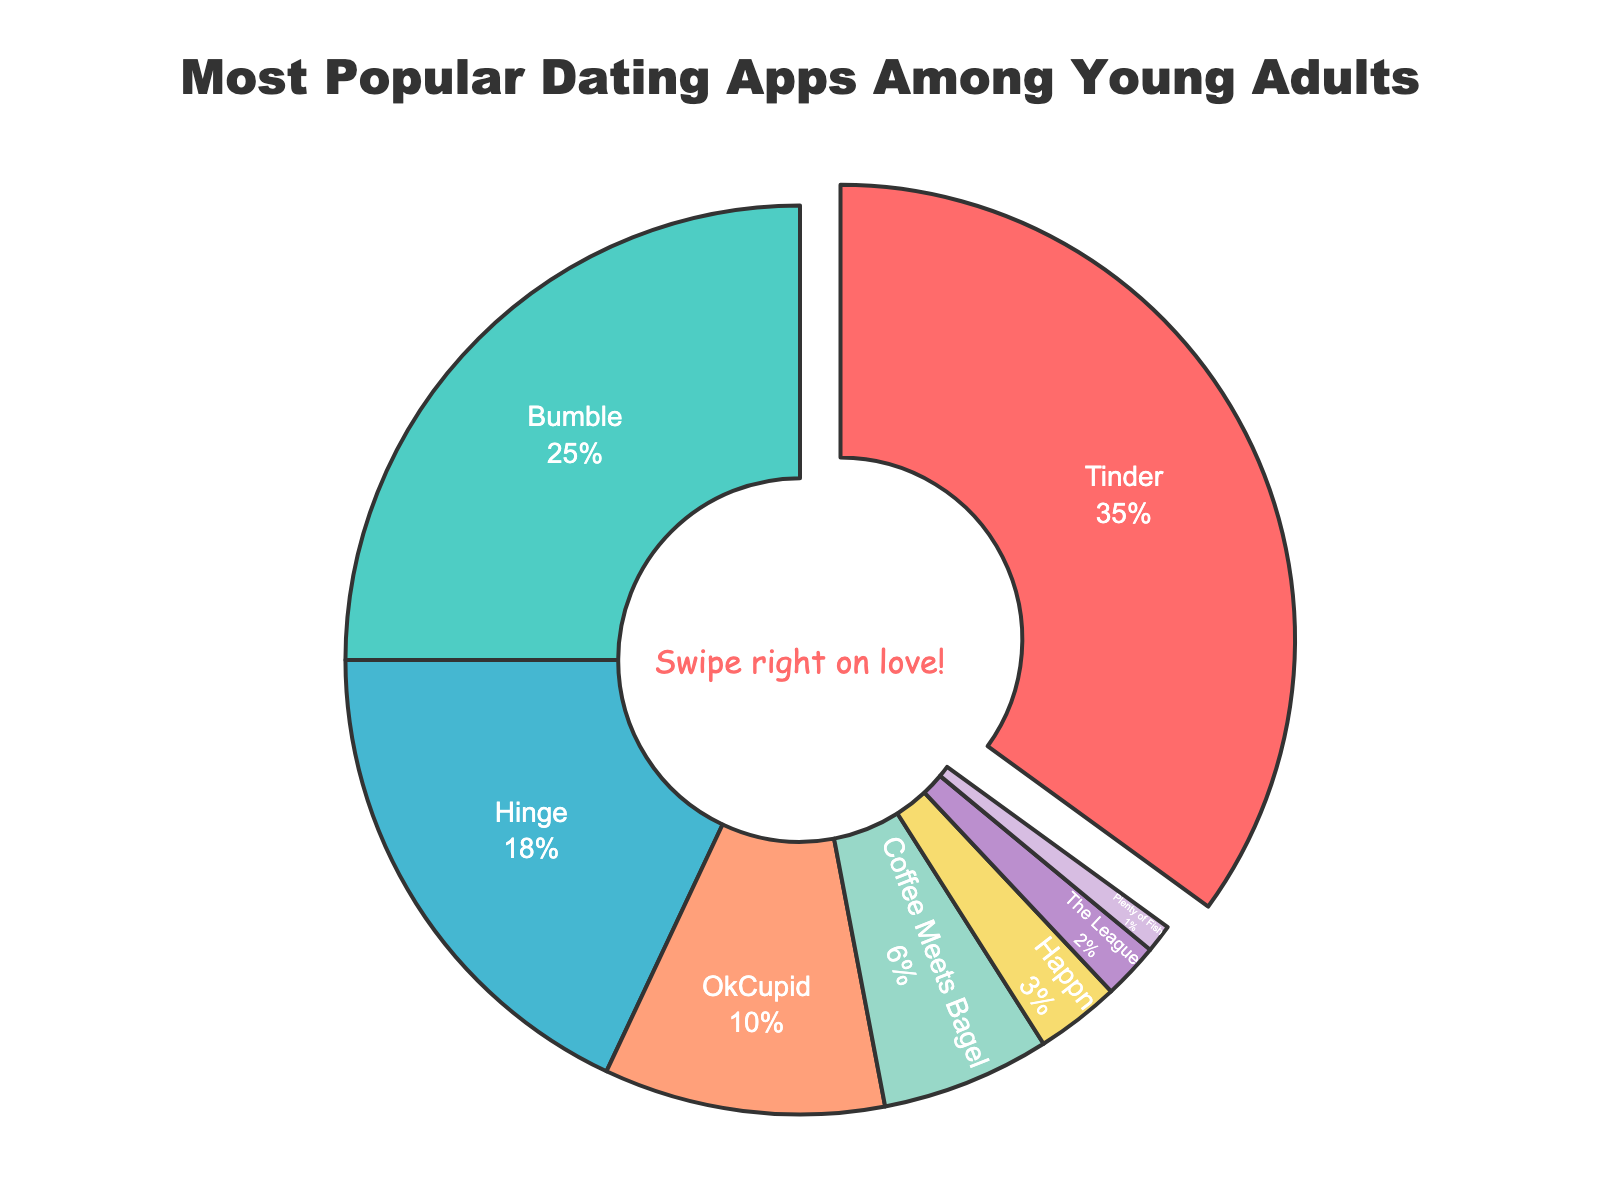What's the most popular dating app among young adults? The pie chart clearly shows that Tinder has the largest segment, which means it's the most popular dating app.
Answer: Tinder Which dating app is the least popular among young adults? The pie chart indicates that Plenty of Fish has the smallest segment, indicating it's the least popular app.
Answer: Plenty of Fish What is the combined percentage of usage for Hinge and Bumble? Add the usage percentages of Hinge and Bumble: 18% + 25% = 43%.
Answer: 43% Does OkCupid have a higher or lower usage percentage than Coffee Meets Bagel? By comparing the segments, OkCupid's segment is larger, indicating it has a higher percentage than Coffee Meets Bagel (10% vs. 6%).
Answer: Higher By how many percentage points is Tinder more popular than Hinge? Subtract Hinge's percentage from Tinder's: 35% - 18% = 17 percentage points.
Answer: 17 What is the total percentage of all dating apps with usage less than 10%? Add the percentages of OkCupid, Coffee Meets Bagel, Happn, The League, and Plenty of Fish: 10% + 6% + 3% + 2% + 1% = 22%.
Answer: 22 Which dating apps have a combined usage percentage of 9%? By adding the percentages of Happn (3%), The League (2%), and Plenty of Fish (1%) together, we get 6%; hence, they don't equal 9%. Only OkCupid (10%) and Coffee Meets Bagel (6%) make sense for checking. Happn + The League = 3% + 2% = 5%, and 6%. Therefore, no combination of these adds to 9%. Coffee Meets Bagel isn't an app as only percentage of 6%.
Answer: None How does the usage of Happn compare with the League? The segment for Happn is larger, indicating it has a higher usage percentage than The League (3% vs. 2%).
Answer: Higher What's the total usage percentage for apps that are more popular than OkCupid but less popular than Tinder? Combine the percentages of Bumble and Hinge: 25% + 18% = 43%.
Answer: 43 What visual element highlights the most popular dating app? The pie chart's segment for Tinder is slightly pulled out, making it more noticeable.
Answer: Pulled out segment 